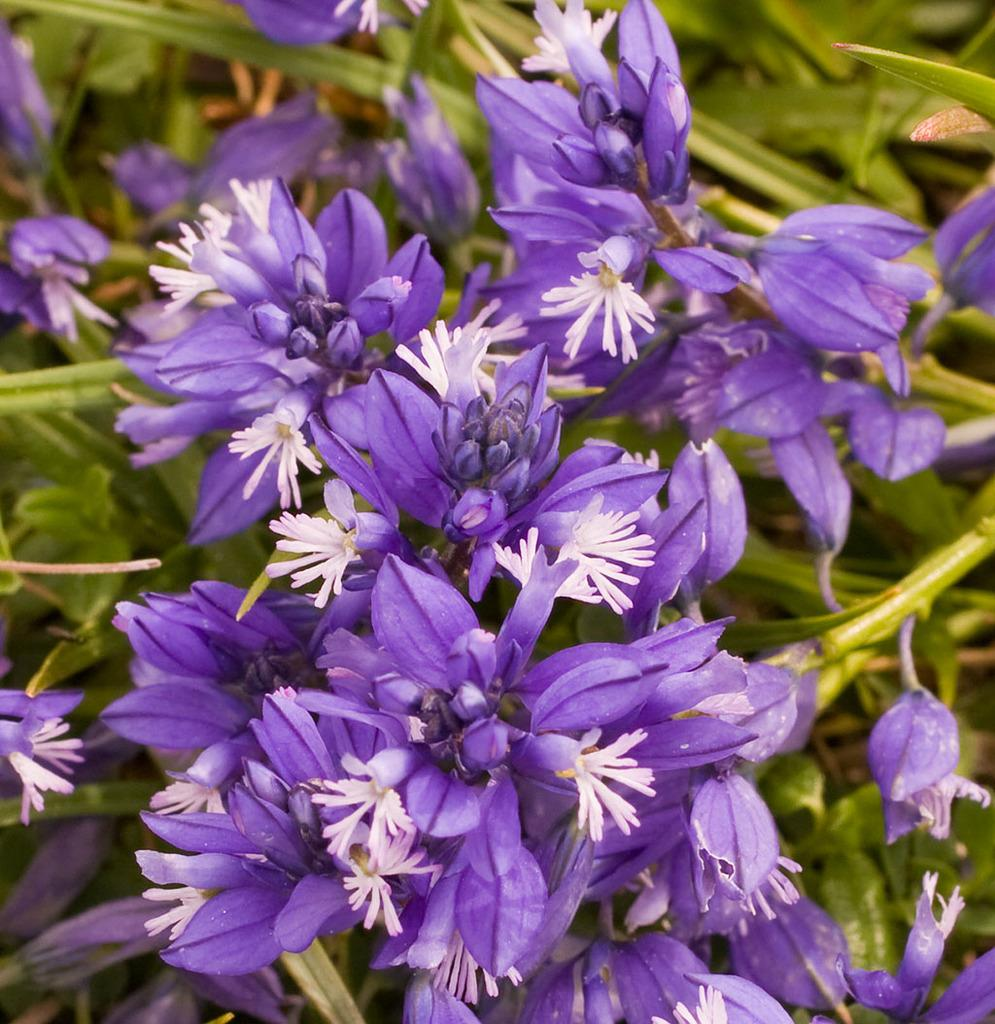What type of plant life is visible in the image? There are flowers, flower buds, and leaves in the image. Can you describe the growth stage of the plants in the image? The image shows both flowers and flower buds, indicating that some plants are in bloom while others are still developing. What is the background of the image like? The background of the image has a blurred view. What type of fuel is being used by the circle in the image? There is no circle or fuel present in the image; it features flowers, flower buds, and leaves with a blurred background. 